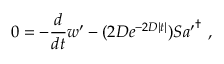<formula> <loc_0><loc_0><loc_500><loc_500>0 = - \frac { d } { d t } w ^ { \prime } - ( 2 D e ^ { - 2 D | t | } ) S { a ^ { \prime } } ^ { \dagger } ,</formula> 